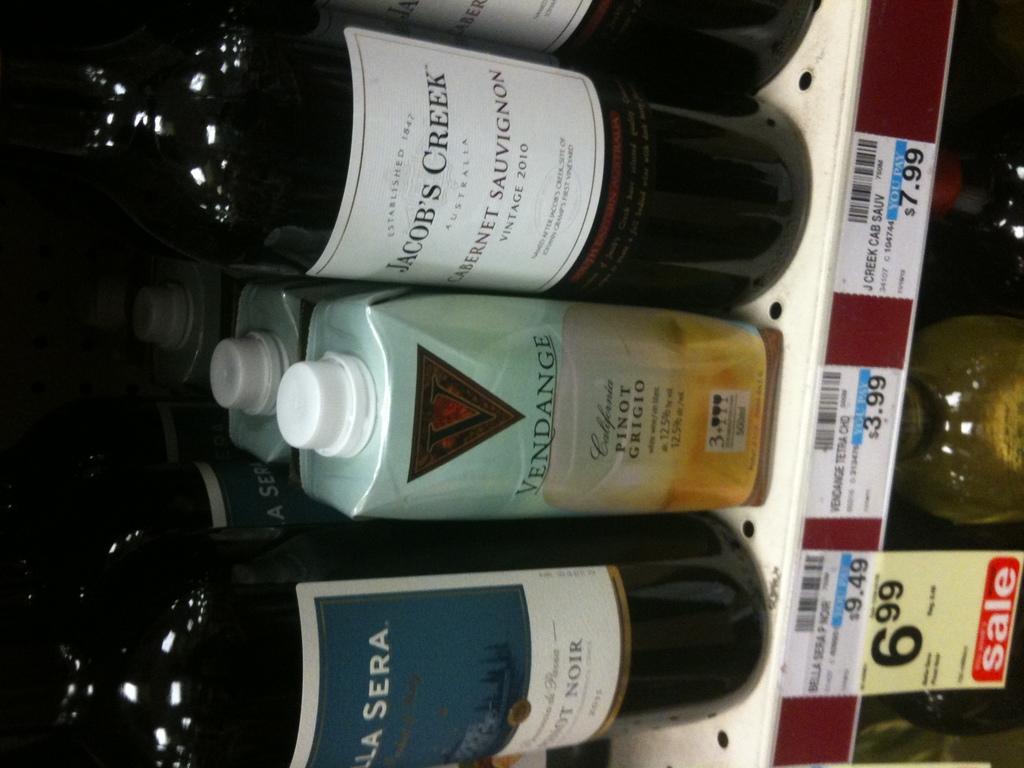What brand of pinot grigio is this?
Make the answer very short. Vendange. 